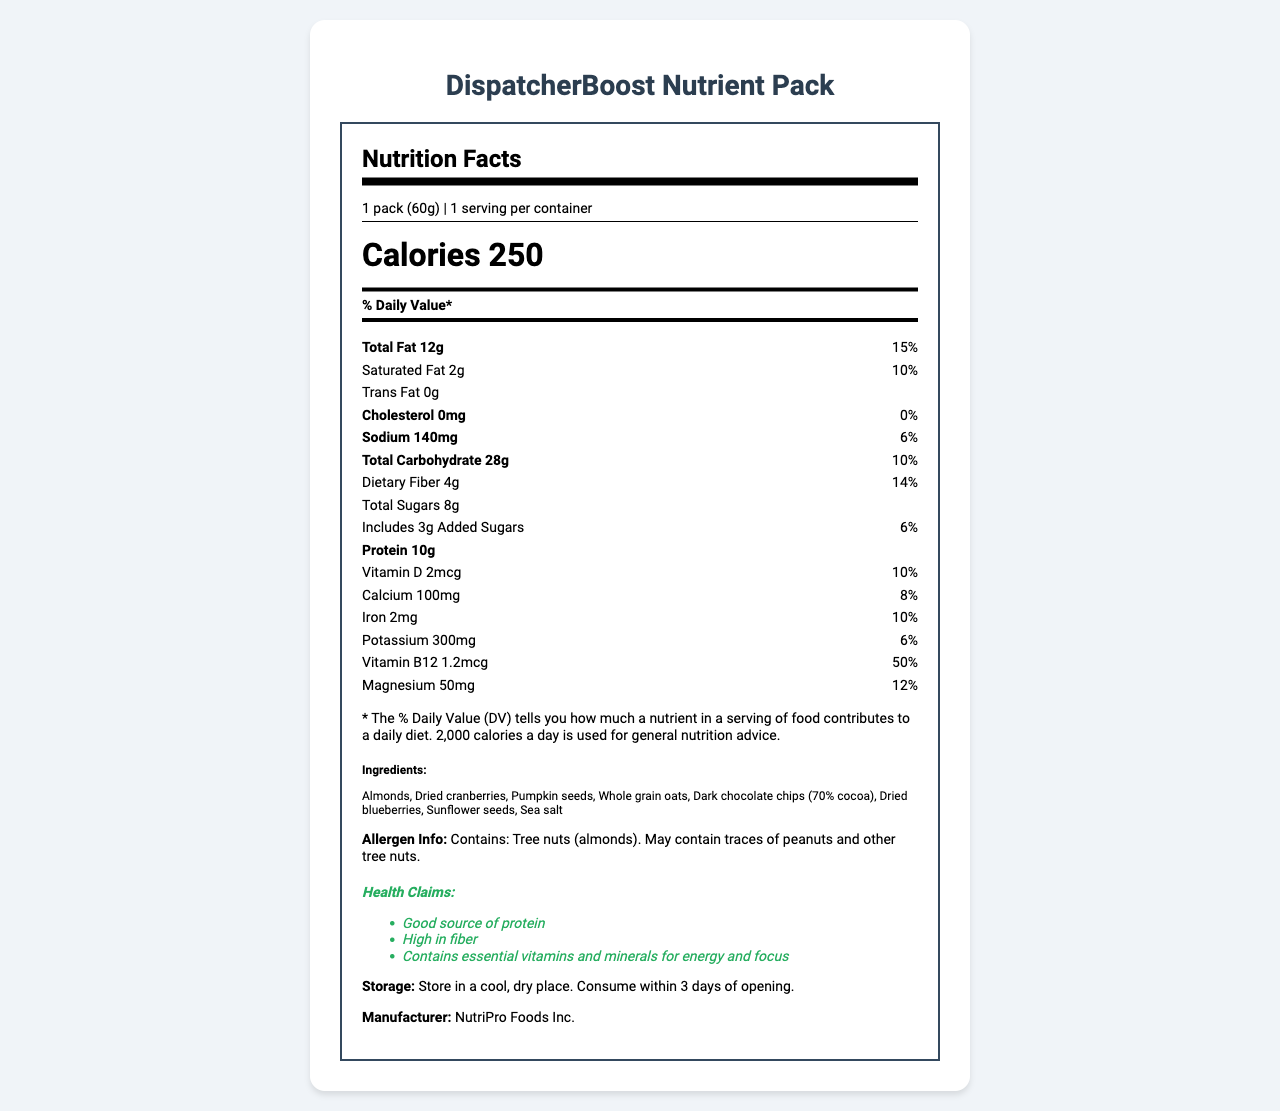what is the serving size? The serving size is explicitly stated as "1 pack (60g)" in the document under the Nutrition Facts section.
Answer: 1 pack (60g) how many calories are in one serving? The document states that one serving contains 250 calories.
Answer: 250 calories name one health claim made for the product One of the health claims listed in the document is "Good source of protein."
Answer: Good source of protein how much protein does the DispatcherBoost Nutrient Pack contain? The document specifies that each pack contains 10g of protein.
Answer: 10g what is the amount of dietary fiber? The amount of dietary fiber is listed as 4g in the Nutrition Facts section of the document.
Answer: 4g how should the DispatcherBoost Nutrient Pack be stored? The storage instructions in the document state that the pack should be stored in a cool, dry place and consumed within 3 days of opening.
Answer: Store in a cool, dry place. Consume within 3 days of opening. which ingredient in the product may cause allergies? A. Almonds B. Dried cranberries C. Sunflower seeds D. Dark chocolate chips The document specifies that the product contains tree nuts (almonds) and may contain traces of peanuts and other tree nuts.
Answer: A which vitamin contributes the highest % Daily Value? A. Vitamin D B. Magnesium C. Vitamin B12 D. Calcium The document lists Vitamin B12 with a 50% Daily Value, which is higher than the others listed.
Answer: C does the DispatcherBoost Nutrient Pack contain trans fat? The document indicates that the product contains 0g of trans fat.
Answer: No summarize the main idea of the document The document includes detailed information about the product's nutritional content, health benefits, instructions for storage, and manufacturer details to help consumers understand what they are consuming and how to manage the product.
Answer: The document describes the nutritional information, ingredients, allergen info, health claims, storage instructions, and manufacturer details for a portable, nutrient-dense snack pack, designed to provide energy and focus for busy professionals. does the document mention where the DispatcherBoost Nutrient Pack is manufactured? The document lists the manufacturer as NutriPro Foods Inc., but does not provide specific details about the manufacturing location.
Answer: Not enough information 